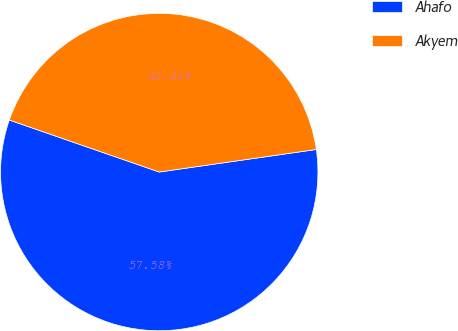<chart> <loc_0><loc_0><loc_500><loc_500><pie_chart><fcel>Ahafo<fcel>Akyem<nl><fcel>57.58%<fcel>42.42%<nl></chart> 